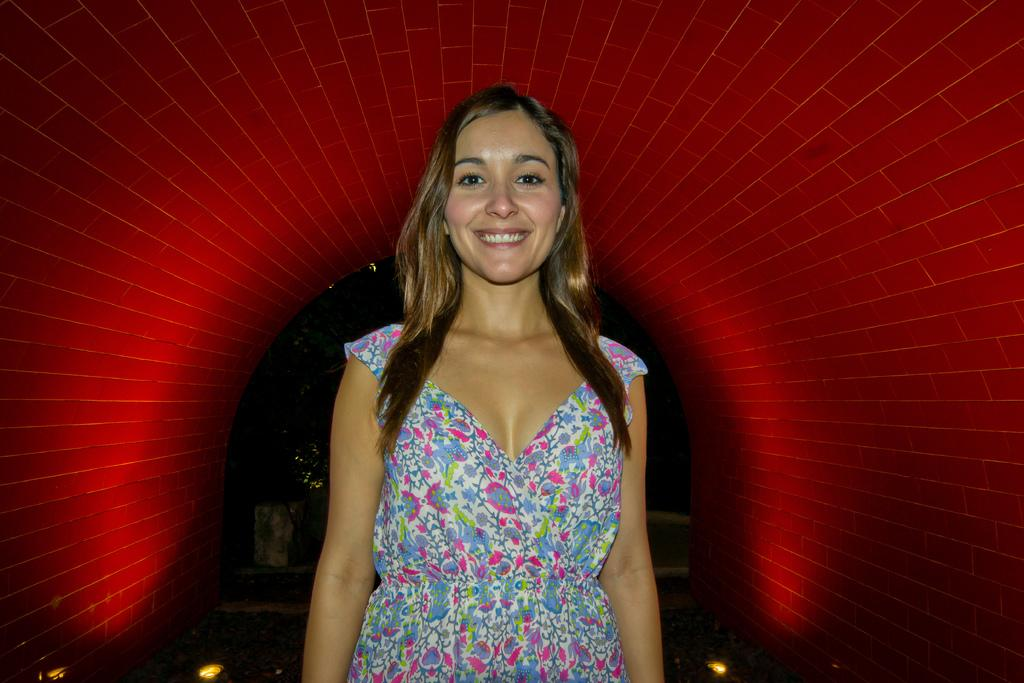Who is present in the image? There is a woman in the image. What can be seen behind the woman? There is a wall visible in the image. What type of fan is the woman holding in the image? There is no fan present in the image. 